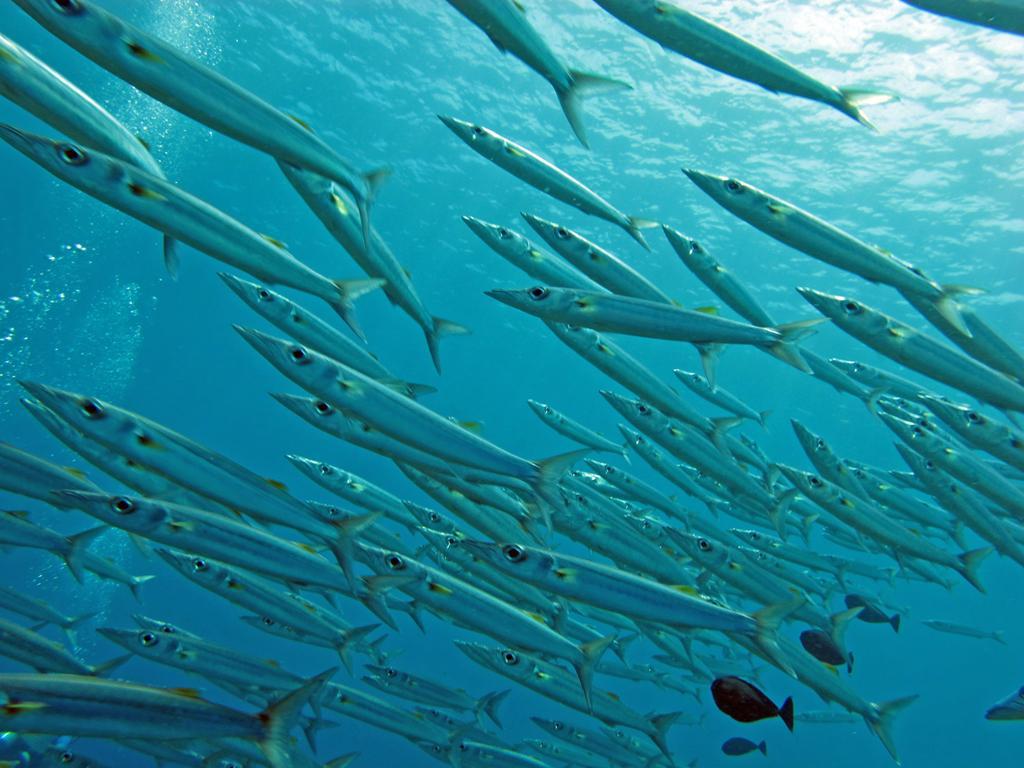Describe this image in one or two sentences. In this image there are flocks of fishes in the water. 